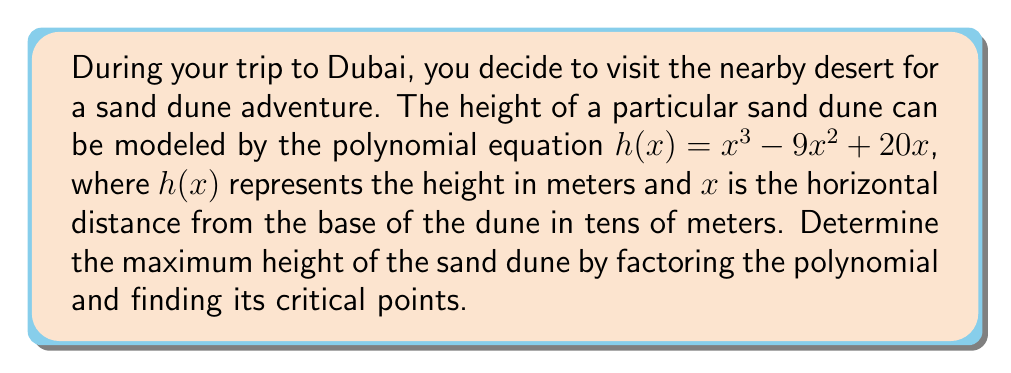Provide a solution to this math problem. To solve this problem, we'll follow these steps:

1) First, let's factor the polynomial $h(x) = x^3 - 9x^2 + 20x$:
   
   $h(x) = x(x^2 - 9x + 20)$
   $h(x) = x(x - 5)(x - 4)$

2) To find the critical points, we need to find where the derivative $h'(x)$ equals zero. The derivative is:

   $h'(x) = (x - 5)(x - 4) + x(x - 4) + x(x - 5)$
   $h'(x) = (x - 5)(x - 4) + x(2x - 9)$
   $h'(x) = x^2 - 9x + 20 + 2x^2 - 9x$
   $h'(x) = 3x^2 - 18x + 20$

3) Now, let's factor $h'(x)$:

   $h'(x) = 3(x^2 - 6x + \frac{20}{3})$
   $h'(x) = 3(x - 3)^2 - 3(\frac{1}{3})$
   $h'(x) = 3(x - 3)^2 - 1$

4) The critical points occur when $h'(x) = 0$:

   $3(x - 3)^2 - 1 = 0$
   $(x - 3)^2 = \frac{1}{3}$
   $x - 3 = \pm \frac{1}{\sqrt{3}}$
   $x = 3 \pm \frac{1}{\sqrt{3}}$

5) The two critical points are:

   $x_1 = 3 + \frac{1}{\sqrt{3}} \approx 3.58$
   $x_2 = 3 - \frac{1}{\sqrt{3}} \approx 2.42$

6) To determine which gives the maximum height, we evaluate $h(x)$ at both points:

   $h(3 + \frac{1}{\sqrt{3}}) \approx 20.21$
   $h(3 - \frac{1}{\sqrt{3}}) \approx 19.21$

Therefore, the maximum height occurs at $x = 3 + \frac{1}{\sqrt{3}}$.
Answer: The maximum height of the sand dune is approximately 20.21 meters, occurring at a horizontal distance of about 35.8 meters from the base of the dune. 